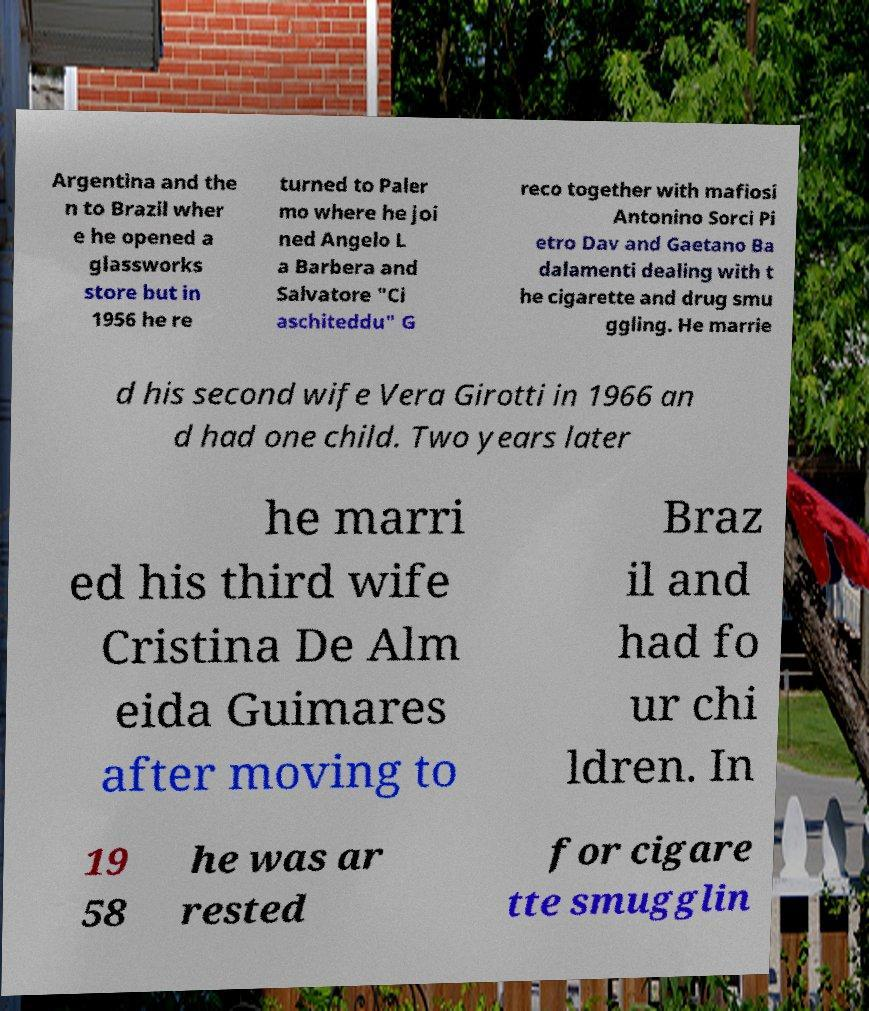Could you extract and type out the text from this image? Argentina and the n to Brazil wher e he opened a glassworks store but in 1956 he re turned to Paler mo where he joi ned Angelo L a Barbera and Salvatore "Ci aschiteddu" G reco together with mafiosi Antonino Sorci Pi etro Dav and Gaetano Ba dalamenti dealing with t he cigarette and drug smu ggling. He marrie d his second wife Vera Girotti in 1966 an d had one child. Two years later he marri ed his third wife Cristina De Alm eida Guimares after moving to Braz il and had fo ur chi ldren. In 19 58 he was ar rested for cigare tte smugglin 